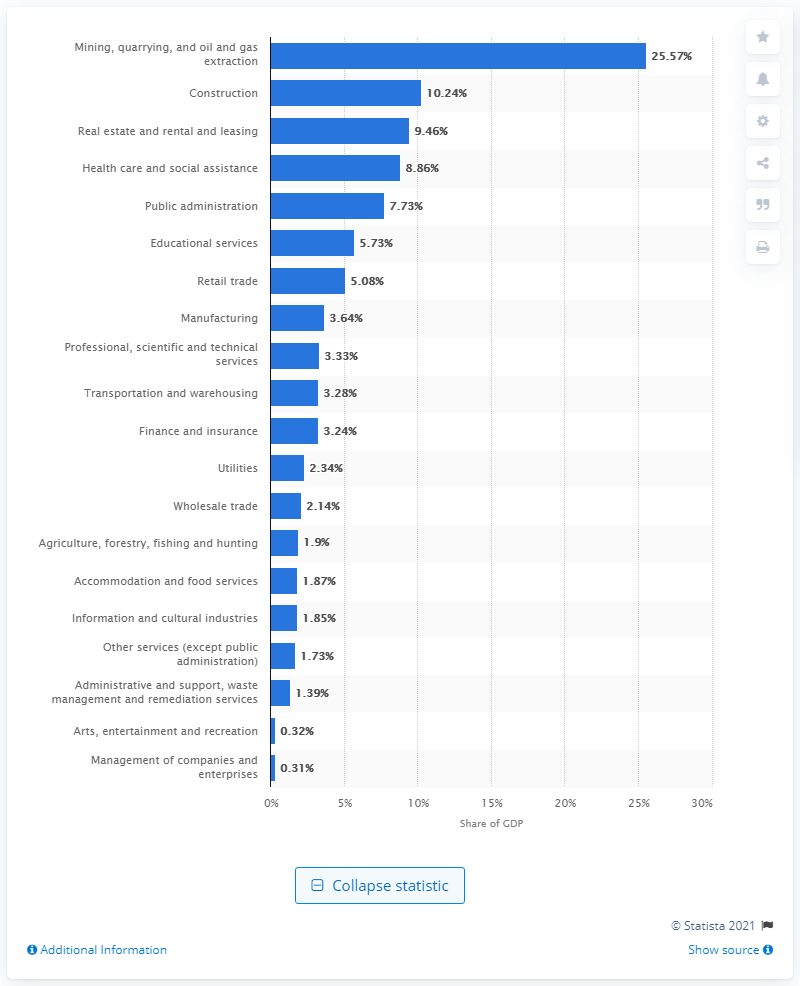Outline some significant characteristics in this image. In 2019, the construction industry accounted for 10.24% of Newfoundland and Labrador's total Gross Domestic Product (GDP). 